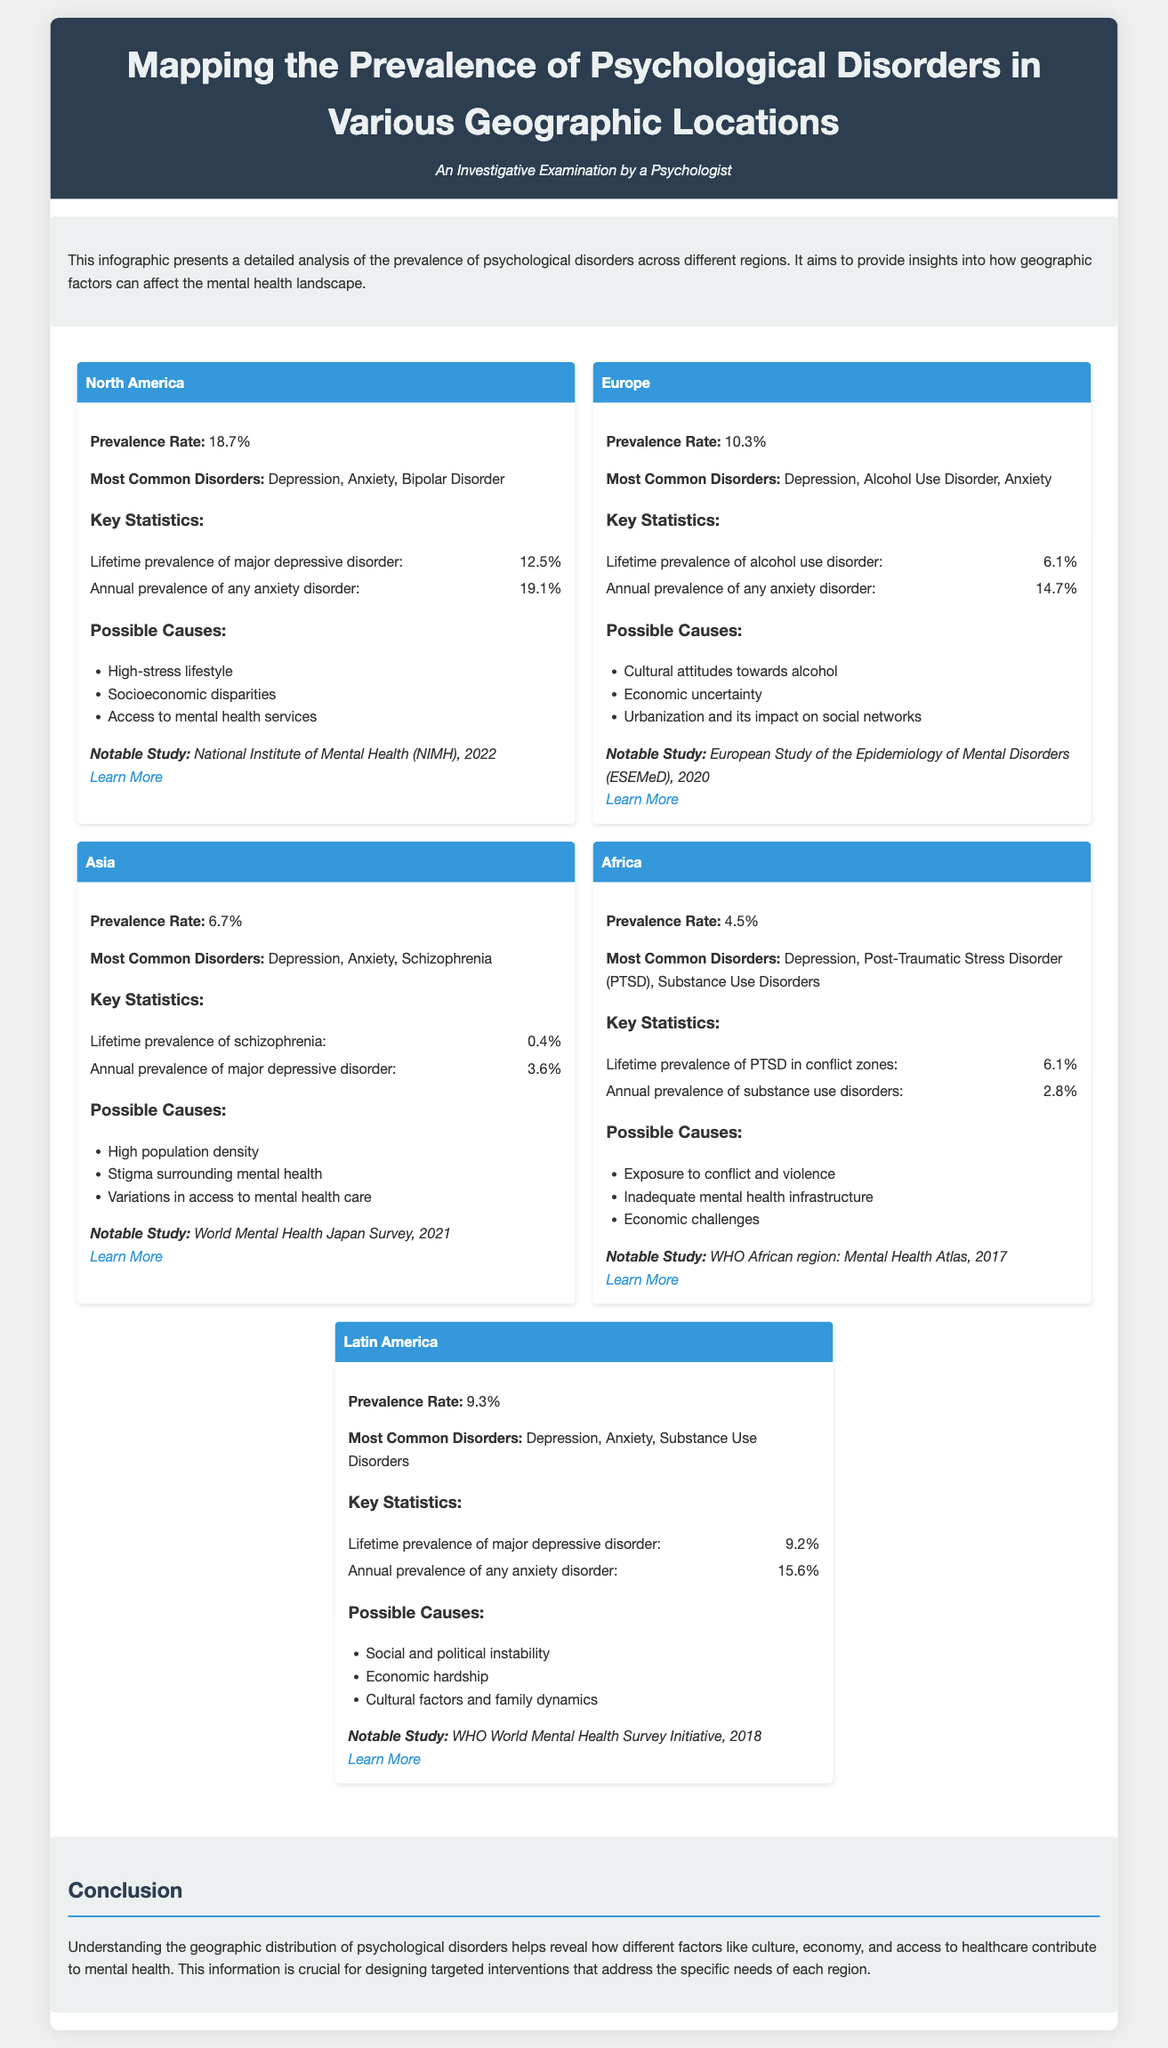What is the prevalence rate of psychological disorders in North America? The prevalence rate for North America is provided under the region section, stating it is 18.7%.
Answer: 18.7% What are the most common disorders in Europe? The document lists the most common disorders in Europe as Depression, Alcohol Use Disorder, and Anxiety.
Answer: Depression, Alcohol Use Disorder, Anxiety What is the lifetime prevalence of major depressive disorder in Latin America? This figure is given in the Latin America section, which states the lifetime prevalence is 9.2%.
Answer: 9.2% Which region has the lowest prevalence rate of psychological disorders? By comparing the prevalence rates, it is evident that Africa has the lowest rate at 4.5%.
Answer: Africa What are possible causes for the psychological disorders in Asia? The document lists several possible causes, including High population density, Stigma surrounding mental health, and Variations in access to mental health care.
Answer: High population density, Stigma surrounding mental health, Variations in access to mental health care Which notable study focused on mental health in North America? The notable study for North America is attributed to the National Institute of Mental Health, referenced as NIMH 2022.
Answer: National Institute of Mental Health (NIMH), 2022 What is the annual prevalence of any anxiety disorder in Europe? The stats provided in the Europe section report that the annual prevalence of any anxiety disorder is 14.7%.
Answer: 14.7% What aspect of psychological disorders does this infographic address? The infographic examines the geographic distribution and prevalence of psychological disorders and how it varies across regions.
Answer: Geographic distribution and prevalence of psychological disorders 